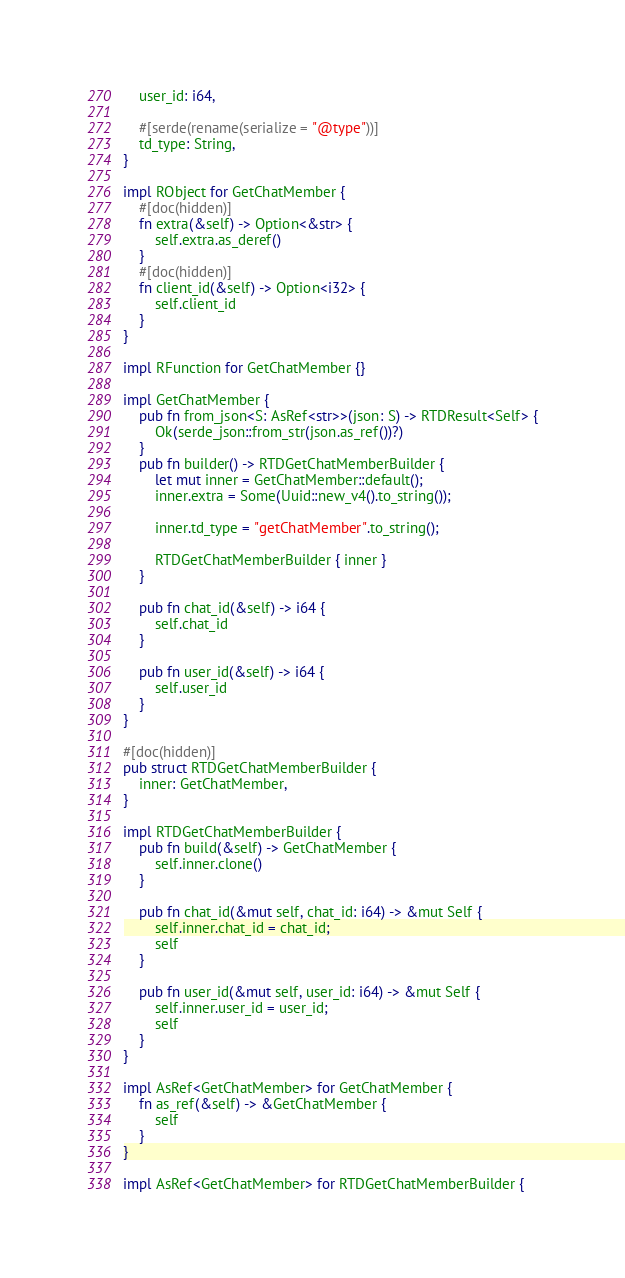Convert code to text. <code><loc_0><loc_0><loc_500><loc_500><_Rust_>    user_id: i64,

    #[serde(rename(serialize = "@type"))]
    td_type: String,
}

impl RObject for GetChatMember {
    #[doc(hidden)]
    fn extra(&self) -> Option<&str> {
        self.extra.as_deref()
    }
    #[doc(hidden)]
    fn client_id(&self) -> Option<i32> {
        self.client_id
    }
}

impl RFunction for GetChatMember {}

impl GetChatMember {
    pub fn from_json<S: AsRef<str>>(json: S) -> RTDResult<Self> {
        Ok(serde_json::from_str(json.as_ref())?)
    }
    pub fn builder() -> RTDGetChatMemberBuilder {
        let mut inner = GetChatMember::default();
        inner.extra = Some(Uuid::new_v4().to_string());

        inner.td_type = "getChatMember".to_string();

        RTDGetChatMemberBuilder { inner }
    }

    pub fn chat_id(&self) -> i64 {
        self.chat_id
    }

    pub fn user_id(&self) -> i64 {
        self.user_id
    }
}

#[doc(hidden)]
pub struct RTDGetChatMemberBuilder {
    inner: GetChatMember,
}

impl RTDGetChatMemberBuilder {
    pub fn build(&self) -> GetChatMember {
        self.inner.clone()
    }

    pub fn chat_id(&mut self, chat_id: i64) -> &mut Self {
        self.inner.chat_id = chat_id;
        self
    }

    pub fn user_id(&mut self, user_id: i64) -> &mut Self {
        self.inner.user_id = user_id;
        self
    }
}

impl AsRef<GetChatMember> for GetChatMember {
    fn as_ref(&self) -> &GetChatMember {
        self
    }
}

impl AsRef<GetChatMember> for RTDGetChatMemberBuilder {</code> 